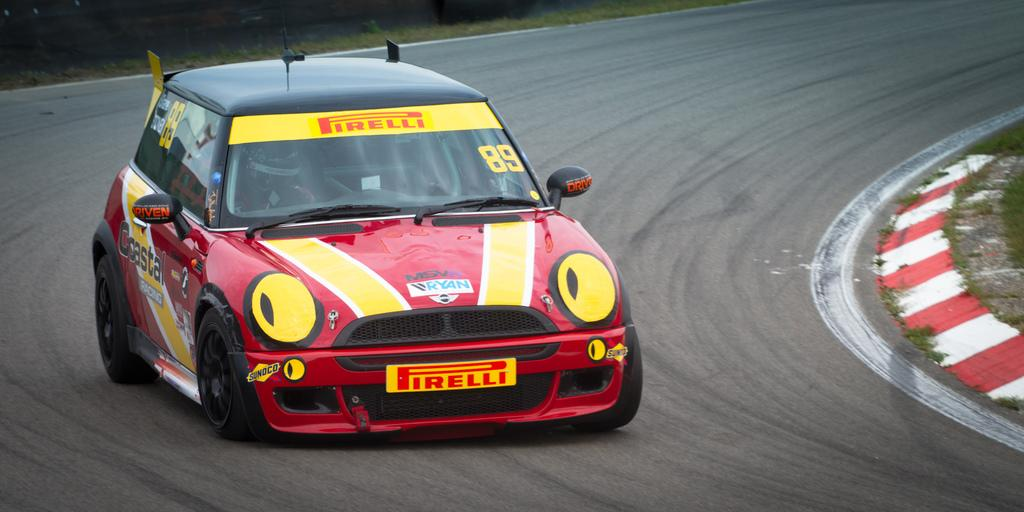What is the main subject of the image? There is a racing car in the image. Where is the racing car located? The racing car is on the road. What can be seen in the background of the image? There is grass in the background of the image beside the road. What type of breakfast is being served in the image? There is no breakfast present in the image; it features a racing car on the road. What kind of soda can be seen in the image? There is no soda present in the image; it only shows a racing car on the road and grass in the background. 